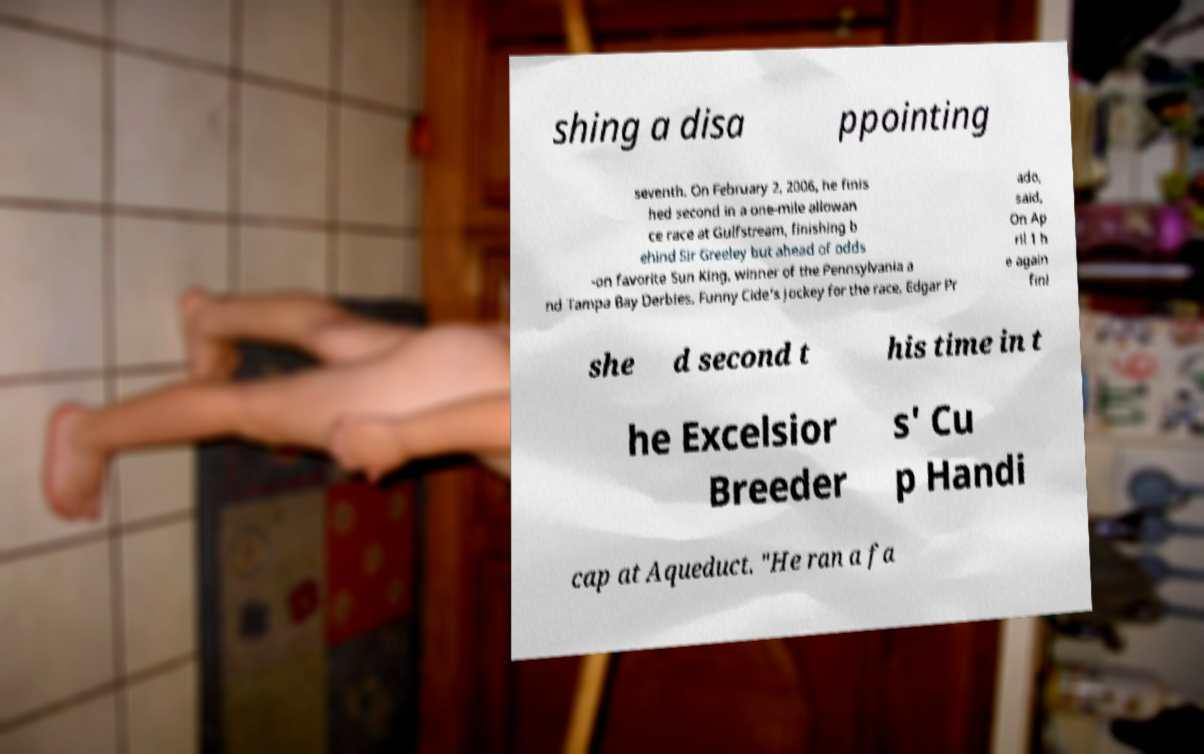Could you assist in decoding the text presented in this image and type it out clearly? shing a disa ppointing seventh. On February 2, 2006, he finis hed second in a one-mile allowan ce race at Gulfstream, finishing b ehind Sir Greeley but ahead of odds -on favorite Sun King, winner of the Pennsylvania a nd Tampa Bay Derbies. Funny Cide's jockey for the race, Edgar Pr ado, said, On Ap ril 1 h e again fini she d second t his time in t he Excelsior Breeder s' Cu p Handi cap at Aqueduct. "He ran a fa 